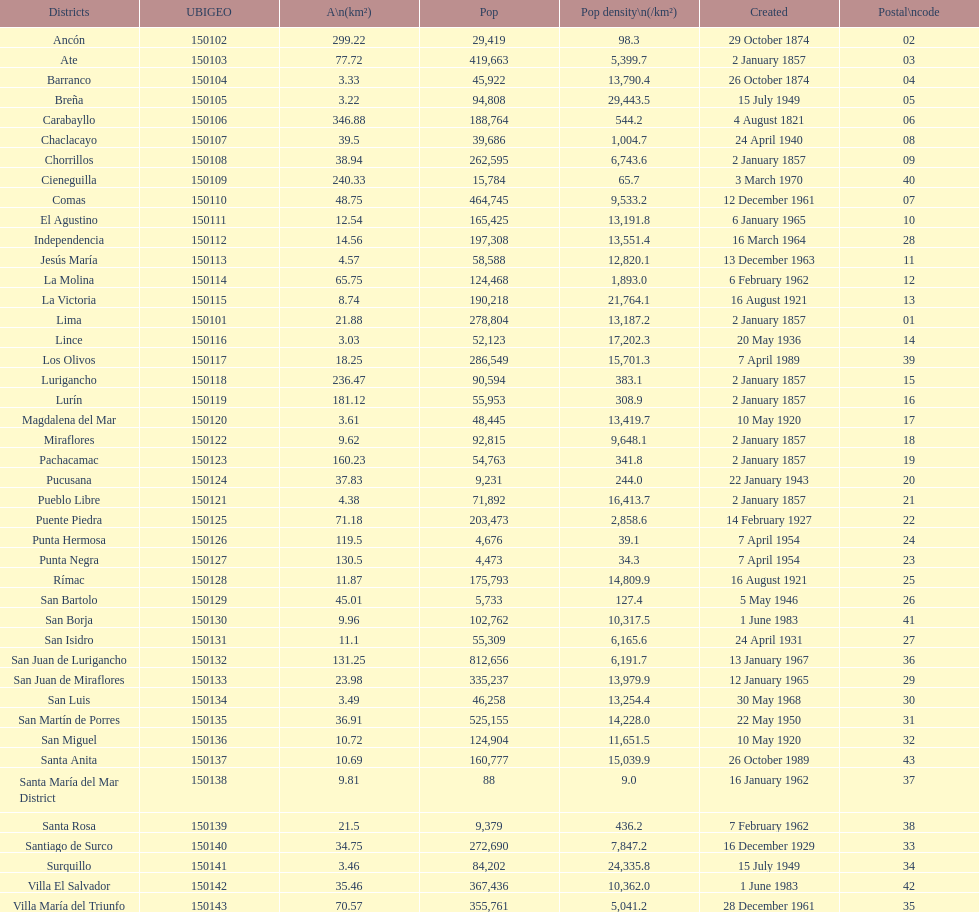What is the total number of districts created in the 1900's? 32. 